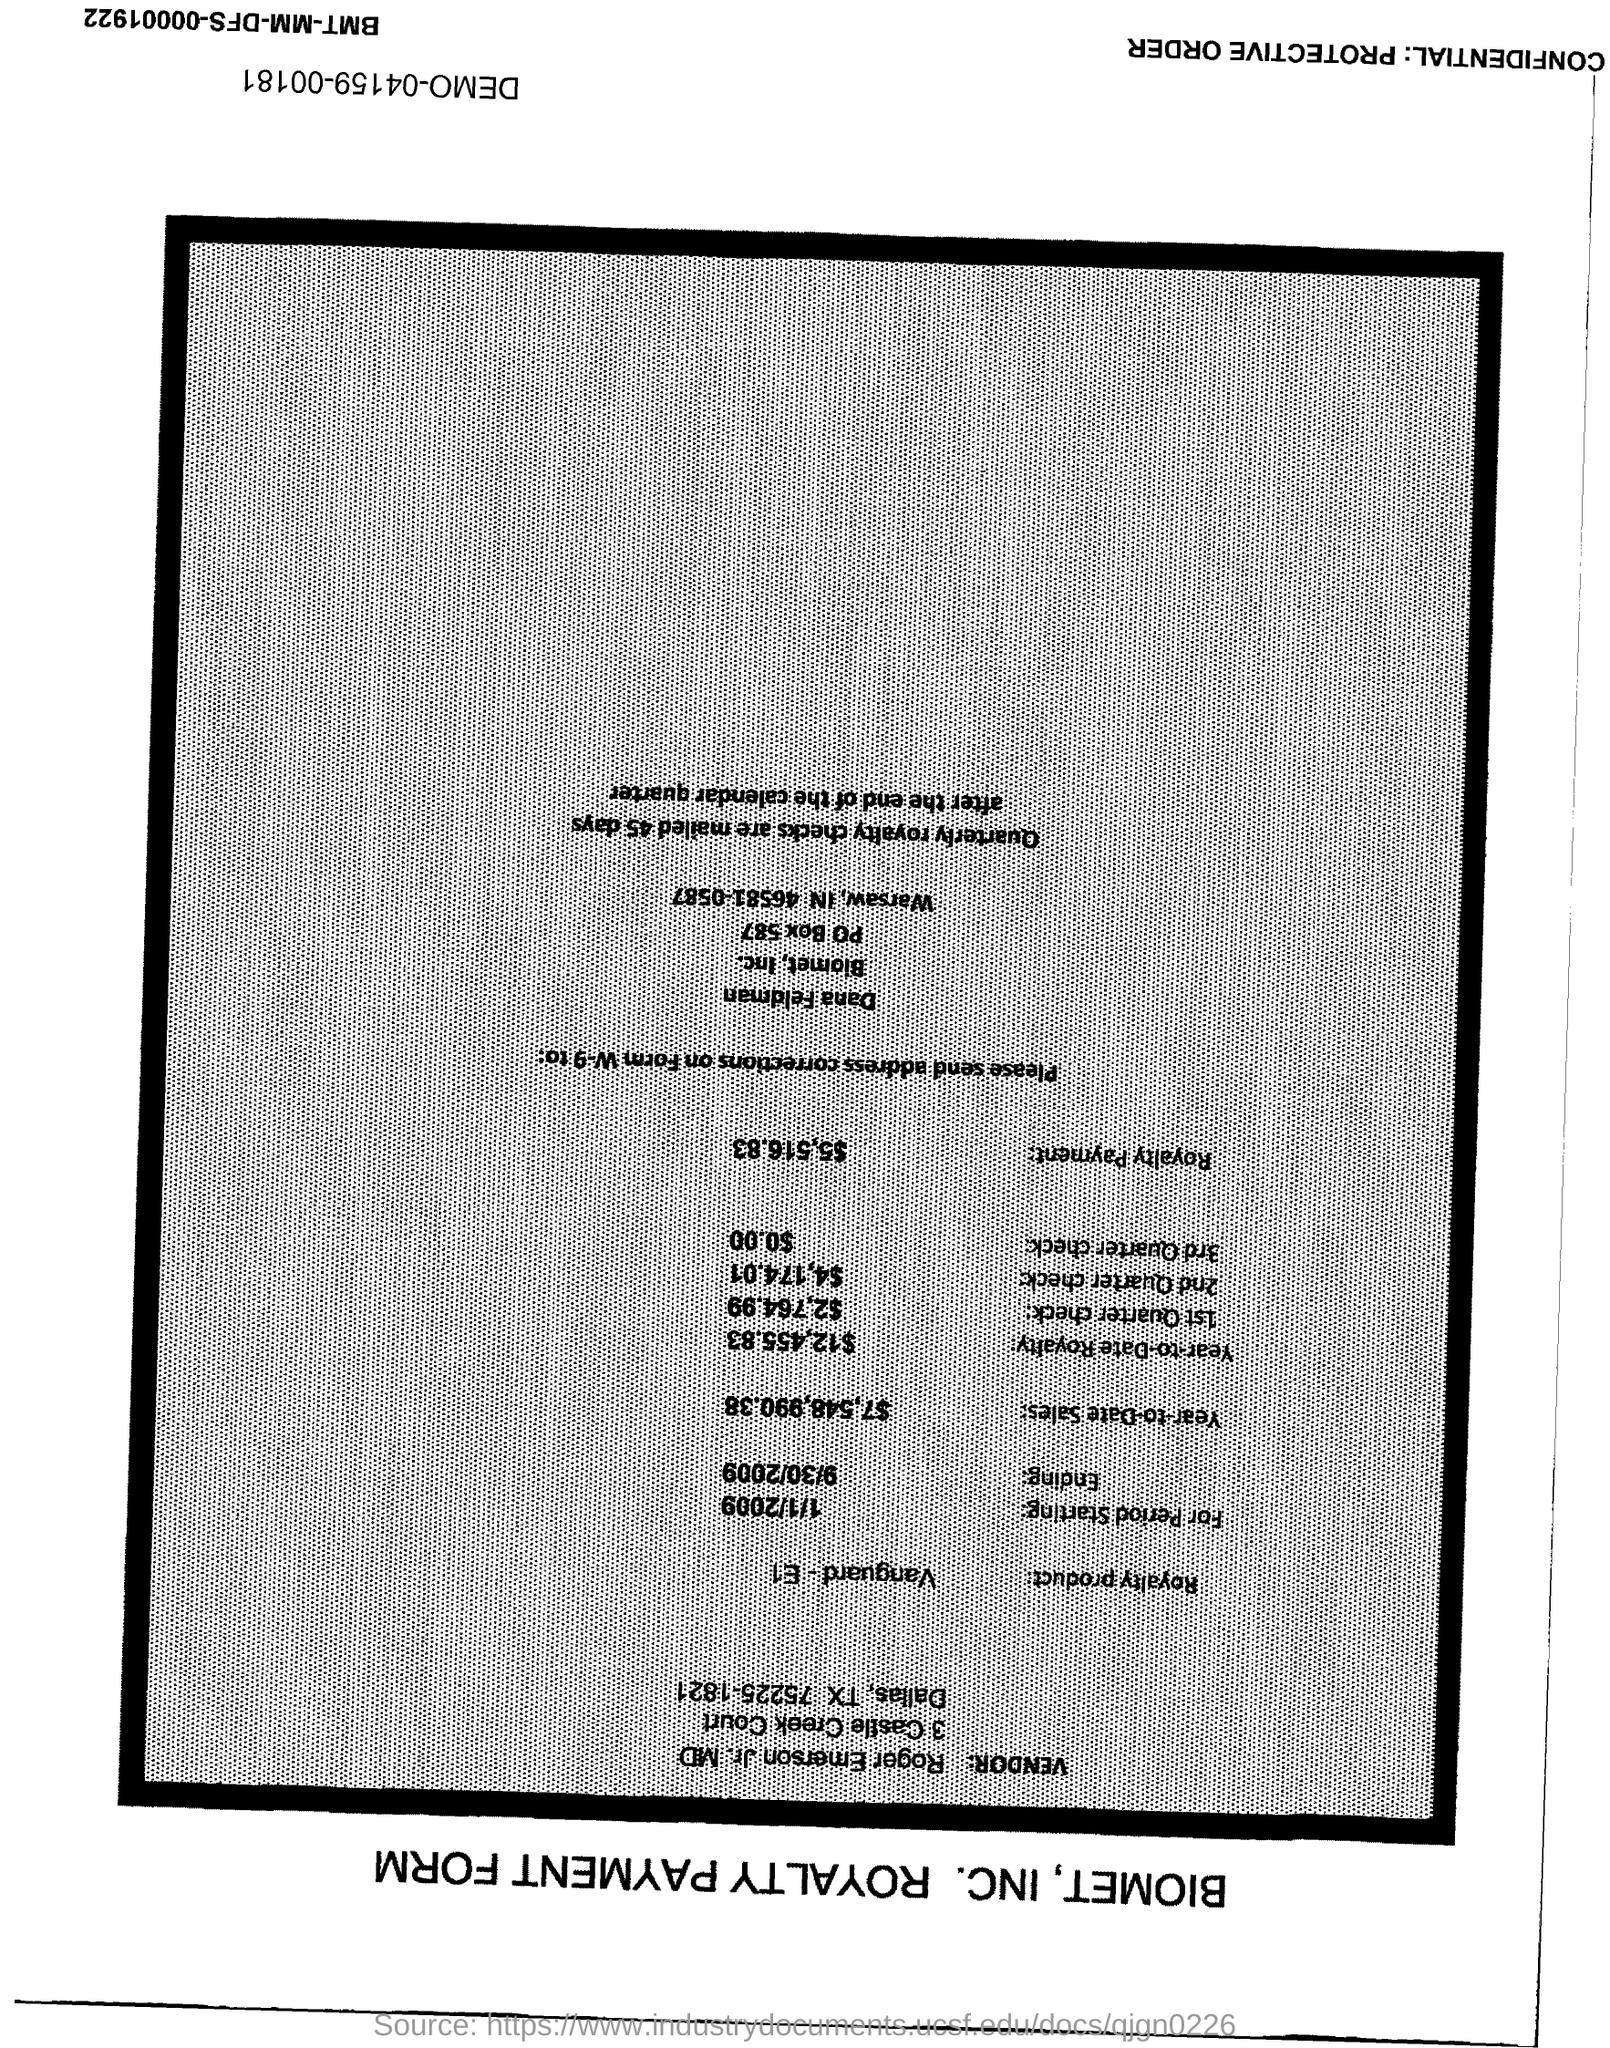Specify some key components in this picture. The royalty payment is $5,516.83. As of right now, the year-to-date royalty amount is $12,455.83. The current year-to-date sales amount is $7,548,990.38. 